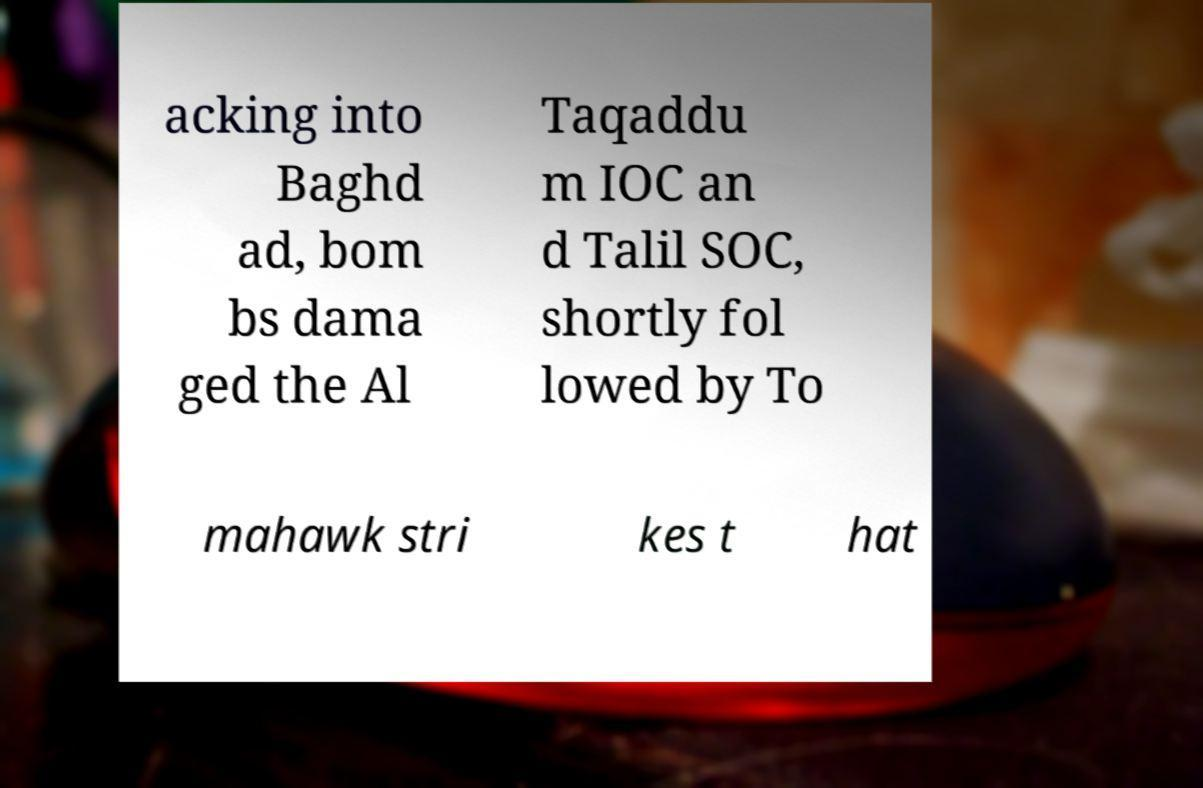There's text embedded in this image that I need extracted. Can you transcribe it verbatim? acking into Baghd ad, bom bs dama ged the Al Taqaddu m IOC an d Talil SOC, shortly fol lowed by To mahawk stri kes t hat 